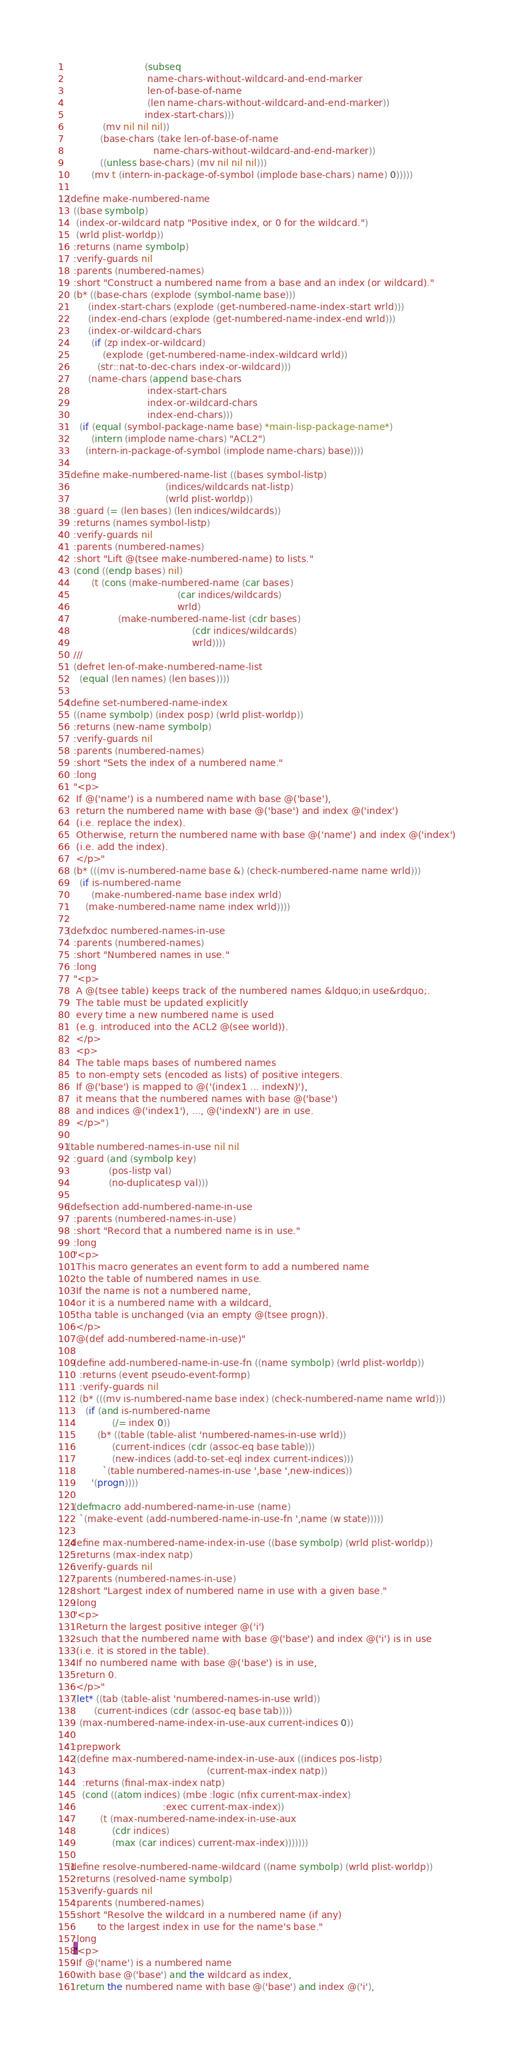<code> <loc_0><loc_0><loc_500><loc_500><_Lisp_>                          (subseq
                           name-chars-without-wildcard-and-end-marker
                           len-of-base-of-name
                           (len name-chars-without-wildcard-and-end-marker))
                          index-start-chars)))
            (mv nil nil nil))
           (base-chars (take len-of-base-of-name
                             name-chars-without-wildcard-and-end-marker))
           ((unless base-chars) (mv nil nil nil)))
        (mv t (intern-in-package-of-symbol (implode base-chars) name) 0)))))

(define make-numbered-name
  ((base symbolp)
   (index-or-wildcard natp "Positive index, or 0 for the wildcard.")
   (wrld plist-worldp))
  :returns (name symbolp)
  :verify-guards nil
  :parents (numbered-names)
  :short "Construct a numbered name from a base and an index (or wildcard)."
  (b* ((base-chars (explode (symbol-name base)))
       (index-start-chars (explode (get-numbered-name-index-start wrld)))
       (index-end-chars (explode (get-numbered-name-index-end wrld)))
       (index-or-wildcard-chars
        (if (zp index-or-wildcard)
            (explode (get-numbered-name-index-wildcard wrld))
          (str::nat-to-dec-chars index-or-wildcard)))
       (name-chars (append base-chars
                           index-start-chars
                           index-or-wildcard-chars
                           index-end-chars)))
    (if (equal (symbol-package-name base) *main-lisp-package-name*)
        (intern (implode name-chars) "ACL2")
      (intern-in-package-of-symbol (implode name-chars) base))))

(define make-numbered-name-list ((bases symbol-listp)
                                 (indices/wildcards nat-listp)
                                 (wrld plist-worldp))
  :guard (= (len bases) (len indices/wildcards))
  :returns (names symbol-listp)
  :verify-guards nil
  :parents (numbered-names)
  :short "Lift @(tsee make-numbered-name) to lists."
  (cond ((endp bases) nil)
        (t (cons (make-numbered-name (car bases)
                                     (car indices/wildcards)
                                     wrld)
                 (make-numbered-name-list (cdr bases)
                                          (cdr indices/wildcards)
                                          wrld))))
  ///
  (defret len-of-make-numbered-name-list
    (equal (len names) (len bases))))

(define set-numbered-name-index
  ((name symbolp) (index posp) (wrld plist-worldp))
  :returns (new-name symbolp)
  :verify-guards nil
  :parents (numbered-names)
  :short "Sets the index of a numbered name."
  :long
  "<p>
   If @('name') is a numbered name with base @('base'),
   return the numbered name with base @('base') and index @('index')
   (i.e. replace the index).
   Otherwise, return the numbered name with base @('name') and index @('index')
   (i.e. add the index).
   </p>"
  (b* (((mv is-numbered-name base &) (check-numbered-name name wrld)))
    (if is-numbered-name
        (make-numbered-name base index wrld)
      (make-numbered-name name index wrld))))

(defxdoc numbered-names-in-use
  :parents (numbered-names)
  :short "Numbered names in use."
  :long
  "<p>
   A @(tsee table) keeps track of the numbered names &ldquo;in use&rdquo;.
   The table must be updated explicitly
   every time a new numbered name is used
   (e.g. introduced into the ACL2 @(see world)).
   </p>
   <p>
   The table maps bases of numbered names
   to non-empty sets (encoded as lists) of positive integers.
   If @('base') is mapped to @('(index1 ... indexN)'),
   it means that the numbered names with base @('base')
   and indices @('index1'), ..., @('indexN') are in use.
   </p>")

(table numbered-names-in-use nil nil
  :guard (and (symbolp key)
              (pos-listp val)
              (no-duplicatesp val)))

(defsection add-numbered-name-in-use
  :parents (numbered-names-in-use)
  :short "Record that a numbered name is in use."
  :long
  "<p>
   This macro generates an event form to add a numbered name
   to the table of numbered names in use.
   If the name is not a numbered name,
   or it is a numbered name with a wildcard,
   tha table is unchanged (via an empty @(tsee progn)).
   </p>
   @(def add-numbered-name-in-use)"

  (define add-numbered-name-in-use-fn ((name symbolp) (wrld plist-worldp))
    :returns (event pseudo-event-formp)
    :verify-guards nil
    (b* (((mv is-numbered-name base index) (check-numbered-name name wrld)))
      (if (and is-numbered-name
               (/= index 0))
          (b* ((table (table-alist 'numbered-names-in-use wrld))
               (current-indices (cdr (assoc-eq base table)))
               (new-indices (add-to-set-eql index current-indices)))
            `(table numbered-names-in-use ',base ',new-indices))
        '(progn))))

  (defmacro add-numbered-name-in-use (name)
    `(make-event (add-numbered-name-in-use-fn ',name (w state)))))

(define max-numbered-name-index-in-use ((base symbolp) (wrld plist-worldp))
  :returns (max-index natp)
  :verify-guards nil
  :parents (numbered-names-in-use)
  :short "Largest index of numbered name in use with a given base."
  :long
  "<p>
   Return the largest positive integer @('i')
   such that the numbered name with base @('base') and index @('i') is in use
   (i.e. it is stored in the table).
   If no numbered name with base @('base') is in use,
   return 0.
   </p>"
  (let* ((tab (table-alist 'numbered-names-in-use wrld))
         (current-indices (cdr (assoc-eq base tab))))
    (max-numbered-name-index-in-use-aux current-indices 0))

  :prepwork
  ((define max-numbered-name-index-in-use-aux ((indices pos-listp)
                                               (current-max-index natp))
     :returns (final-max-index natp)
     (cond ((atom indices) (mbe :logic (nfix current-max-index)
                                :exec current-max-index))
           (t (max-numbered-name-index-in-use-aux
               (cdr indices)
               (max (car indices) current-max-index)))))))

(define resolve-numbered-name-wildcard ((name symbolp) (wrld plist-worldp))
  :returns (resolved-name symbolp)
  :verify-guards nil
  :parents (numbered-names)
  :short "Resolve the wildcard in a numbered name (if any)
          to the largest index in use for the name's base."
  :long
  "<p>
   If @('name') is a numbered name
   with base @('base') and the wildcard as index,
   return the numbered name with base @('base') and index @('i'),</code> 